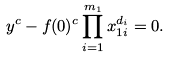<formula> <loc_0><loc_0><loc_500><loc_500>y ^ { c } - f ( 0 ) ^ { c } \prod _ { i = 1 } ^ { m _ { 1 } } x _ { 1 i } ^ { d _ { i } } = 0 .</formula> 